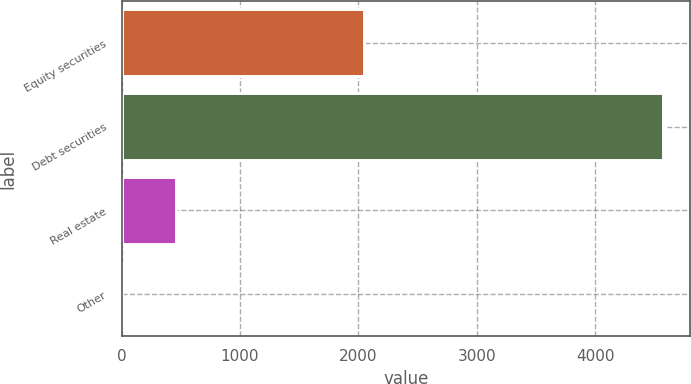Convert chart to OTSL. <chart><loc_0><loc_0><loc_500><loc_500><bar_chart><fcel>Equity securities<fcel>Debt securities<fcel>Real estate<fcel>Other<nl><fcel>2050<fcel>4575<fcel>462<fcel>5<nl></chart> 